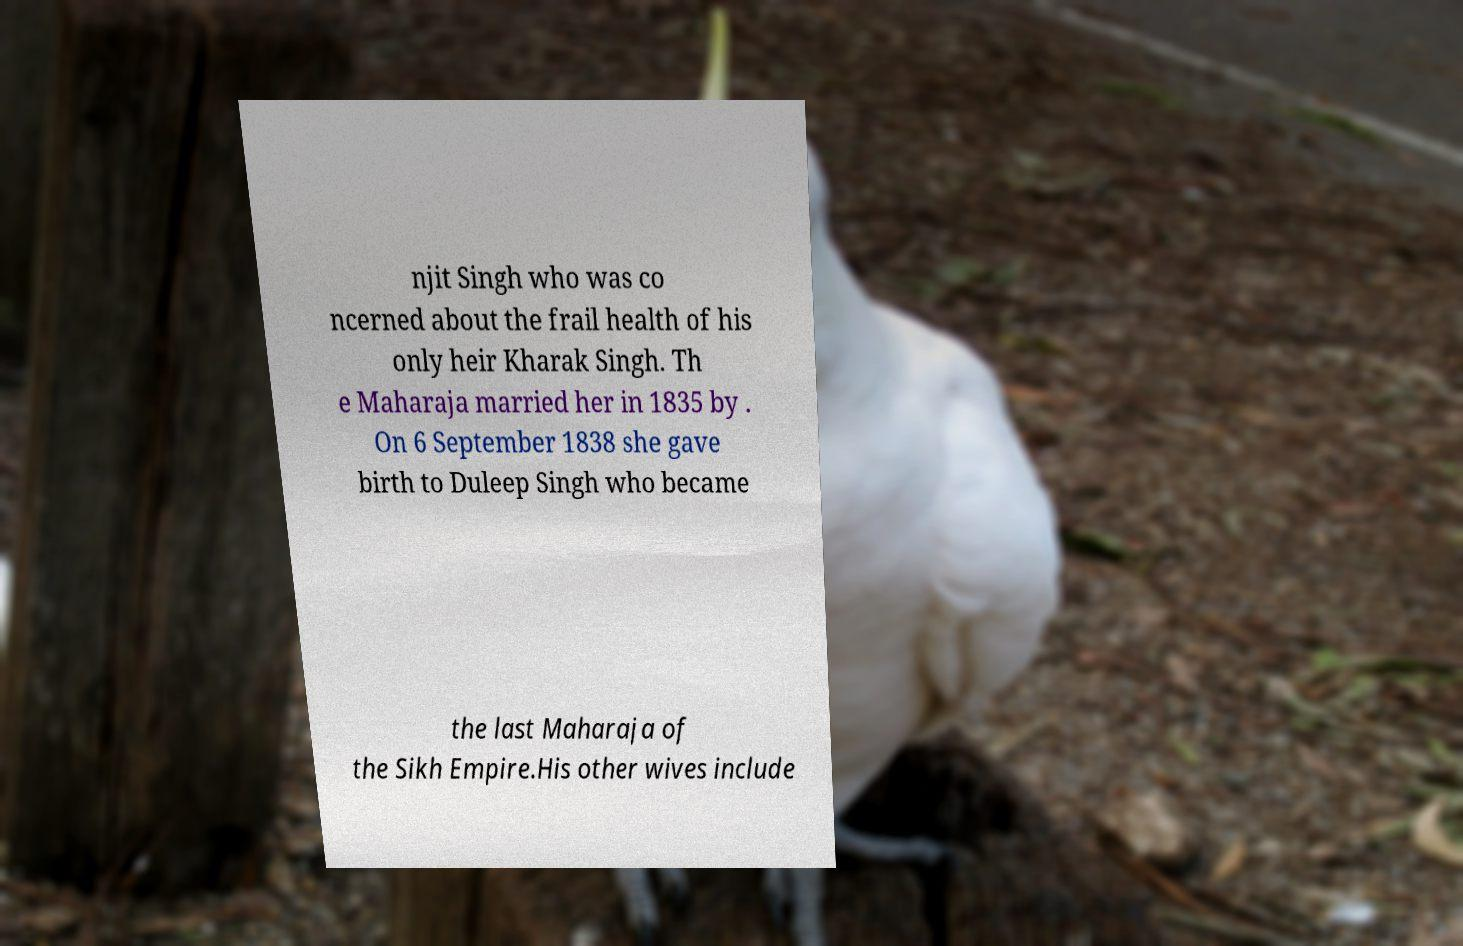There's text embedded in this image that I need extracted. Can you transcribe it verbatim? njit Singh who was co ncerned about the frail health of his only heir Kharak Singh. Th e Maharaja married her in 1835 by . On 6 September 1838 she gave birth to Duleep Singh who became the last Maharaja of the Sikh Empire.His other wives include 